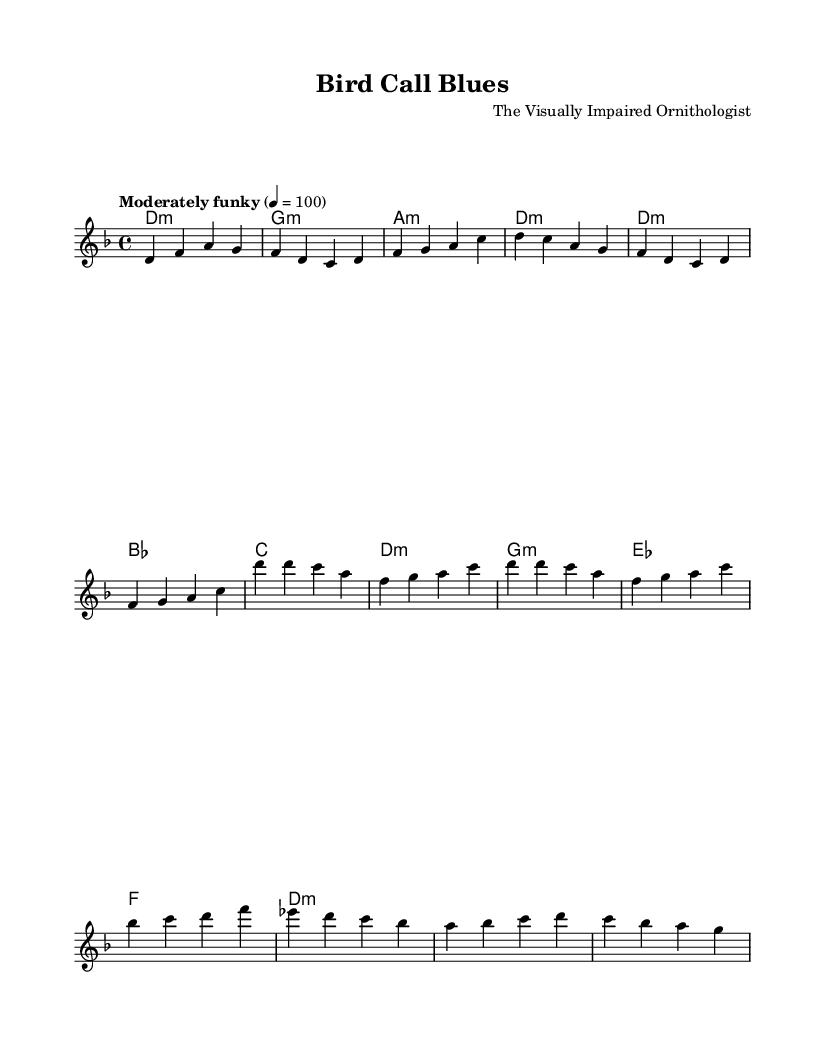What is the key signature of this music? The key signature indicated in the score is D minor, which typically has one flat (B flat).
Answer: D minor What is the time signature of this piece? The score indicates a time signature of 4/4, which means there are four beats in each measure.
Answer: 4/4 What is the tempo marking for this piece? The tempo marking provided in the score is "Moderately funky," indicating the style and pace of the performance.
Answer: Moderately funky How many measures are in the verse section? The verse section consists of four measures based on the melody, which can be counted based on the grouping of the notes.
Answer: 4 What are the primary themes expressed in the lyrics? The lyrics focus on the importance of listening to birds and the need for environmental conservation, as seen in the repeated references to their cries and habitats.
Answer: Conservation Which chord appears at the start of the chorus? The first chord of the chorus is D minor, as indicated in the harmonies section of the score.
Answer: D minor What is the main message conveyed in the bridge lyrics? The bridge emphasizes the need to protect the environment from trees to seas, which reflects a broader message of conservation.
Answer: Protect all these 